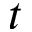<formula> <loc_0><loc_0><loc_500><loc_500>t</formula> 